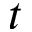<formula> <loc_0><loc_0><loc_500><loc_500>t</formula> 